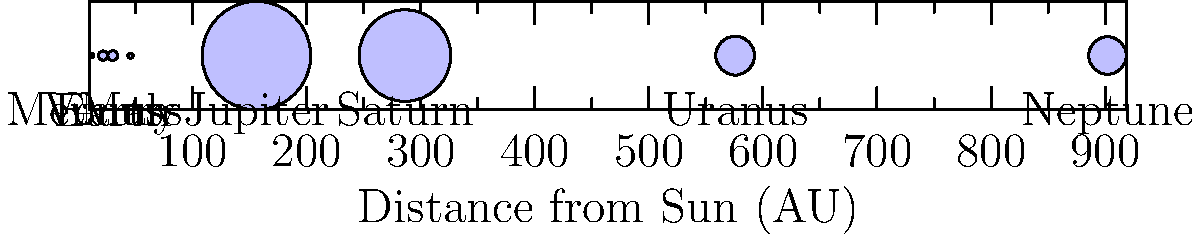As a humanitarian worker dealing with displaced populations, you often need to explain complex concepts in simple terms. If you were to use our solar system as an analogy for refugee displacement, which planet's distance from the Sun would best represent the average distance Syrian refugees have traveled to reach Turkey, assuming Earth represents their home country? To answer this question, we need to follow these steps:

1. Understand the analogy: Earth represents Syria (the home country).
2. Recall that Turkey borders Syria, so the distance traveled is relatively short compared to intercontinental refugee movements.
3. Examine the diagram, focusing on planets close to Earth.
4. Venus is closer to the Sun than Earth, while Mars is farther.
5. The distance from Earth to Mars (1.52 AU - 1 AU = 0.52 AU) is slightly larger than the distance from Venus to Earth (1 AU - 0.72 AU = 0.28 AU).
6. Given that Syrian refugees didn't have to travel very far to reach Turkey, Venus is the better analogy.
7. Venus's distance from the Sun (0.72 AU) compared to Earth's (1 AU) represents a shorter journey, similar to the relatively short distance between Syria and Turkey.
Answer: Venus 